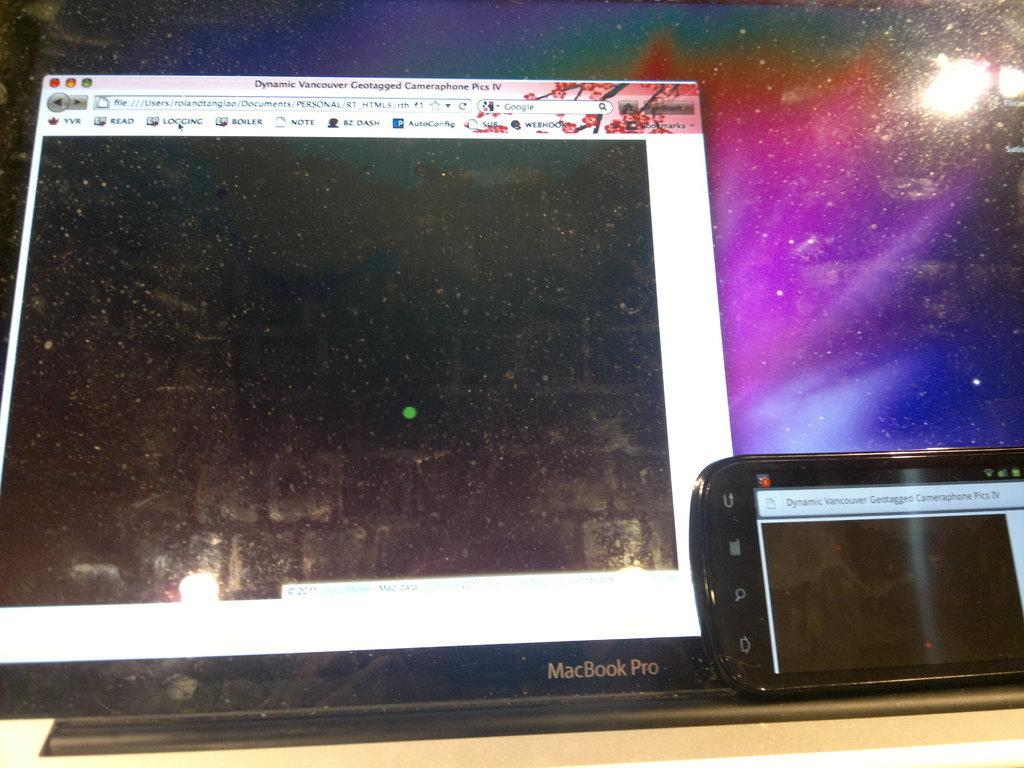<image>
Write a terse but informative summary of the picture. A MacBook pro is displaying a screen where the mouse icon is about to click Logging. 